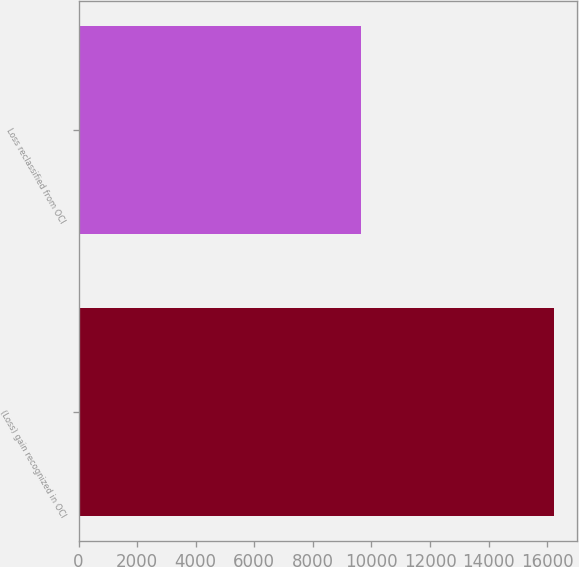Convert chart to OTSL. <chart><loc_0><loc_0><loc_500><loc_500><bar_chart><fcel>(Loss) gain recognized in OCI<fcel>Loss reclassified from OCI<nl><fcel>16215<fcel>9657<nl></chart> 